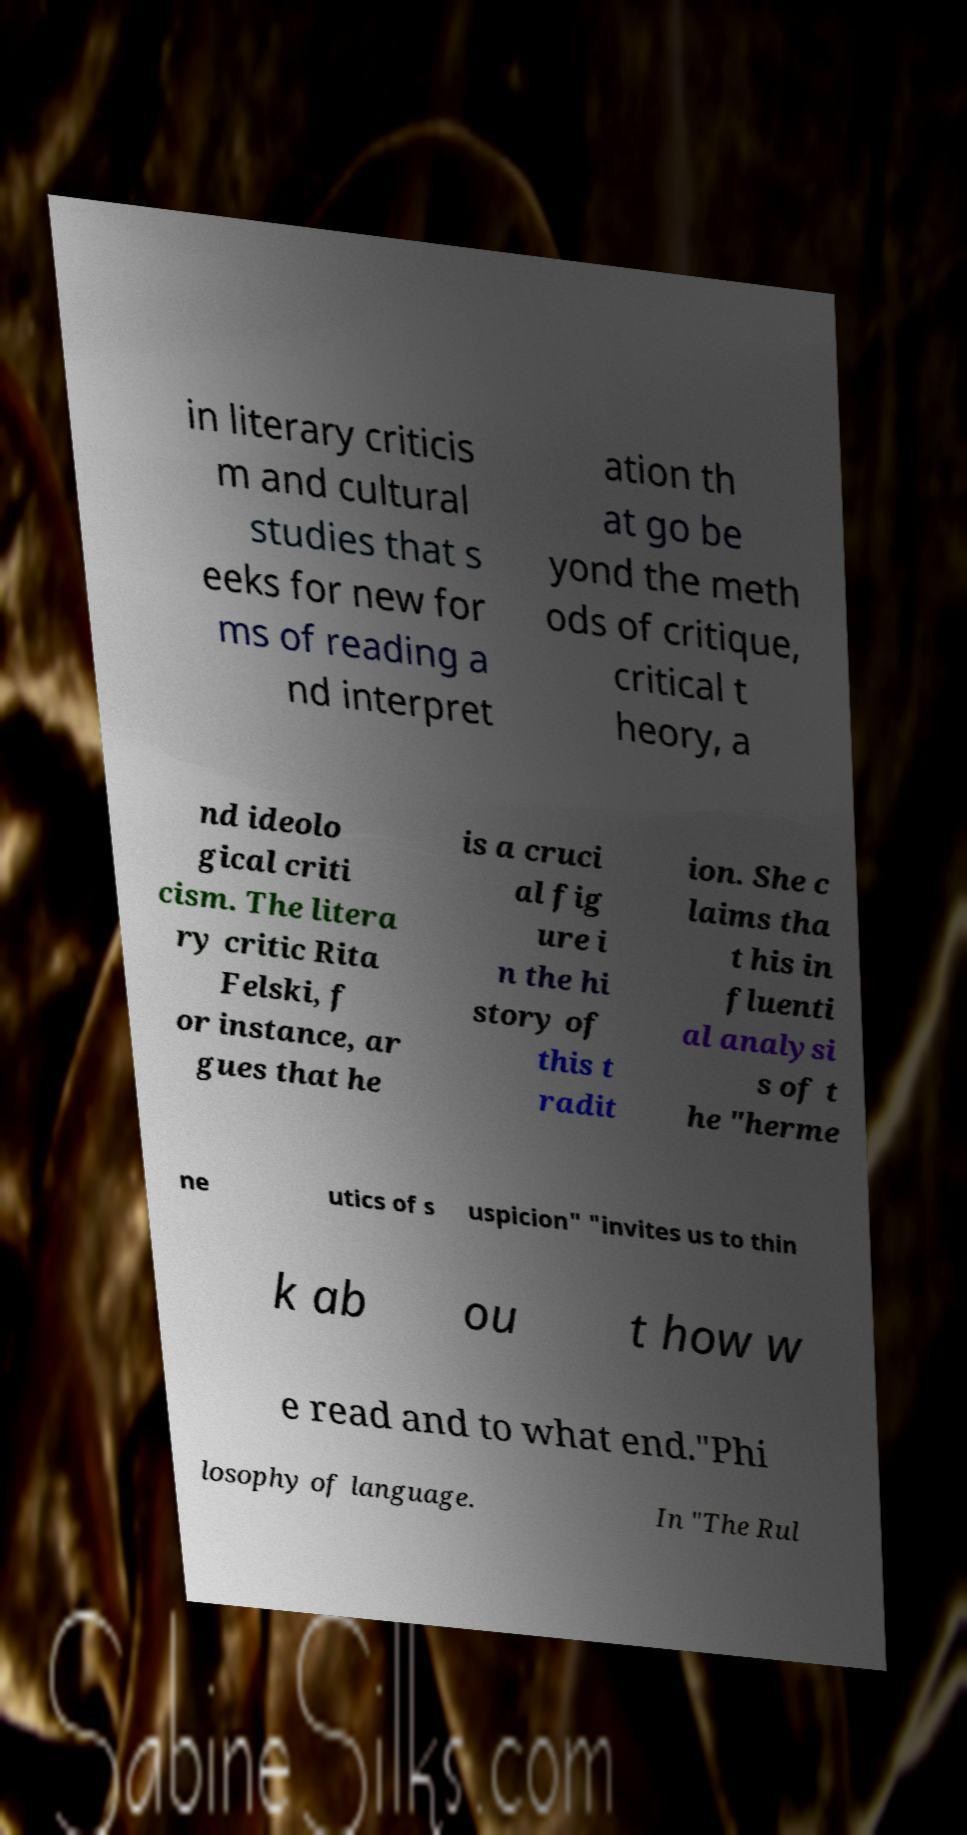Can you accurately transcribe the text from the provided image for me? in literary criticis m and cultural studies that s eeks for new for ms of reading a nd interpret ation th at go be yond the meth ods of critique, critical t heory, a nd ideolo gical criti cism. The litera ry critic Rita Felski, f or instance, ar gues that he is a cruci al fig ure i n the hi story of this t radit ion. She c laims tha t his in fluenti al analysi s of t he "herme ne utics of s uspicion" "invites us to thin k ab ou t how w e read and to what end."Phi losophy of language. In "The Rul 